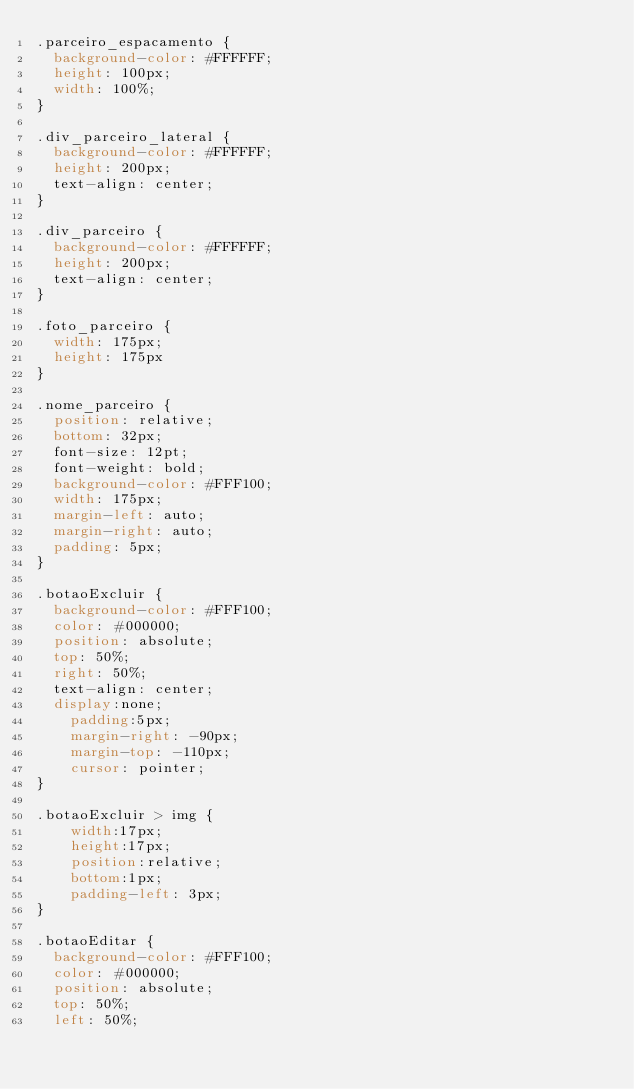Convert code to text. <code><loc_0><loc_0><loc_500><loc_500><_CSS_>.parceiro_espacamento {
	background-color: #FFFFFF;
	height: 100px;
	width: 100%;
}

.div_parceiro_lateral {
	background-color: #FFFFFF;
	height: 200px;
	text-align: center;
}

.div_parceiro {
	background-color: #FFFFFF;
	height: 200px;
	text-align: center;
}

.foto_parceiro {
	width: 175px;
	height: 175px
}

.nome_parceiro {
	position: relative;
	bottom: 32px;
	font-size: 12pt;
	font-weight: bold;
	background-color: #FFF100;
	width: 175px;
	margin-left: auto;
	margin-right: auto;
	padding: 5px;
}

.botaoExcluir {
	background-color: #FFF100;
	color: #000000;
	position: absolute;
	top: 50%;
	right: 50%;
	text-align: center;
	display:none;
    padding:5px;
    margin-right: -90px;
    margin-top: -110px;
    cursor: pointer;
}

.botaoExcluir > img {
    width:17px;
    height:17px;
    position:relative;
    bottom:1px;
    padding-left: 3px;
}

.botaoEditar {
	background-color: #FFF100;
	color: #000000;
	position: absolute;
	top: 50%;
	left: 50%;</code> 